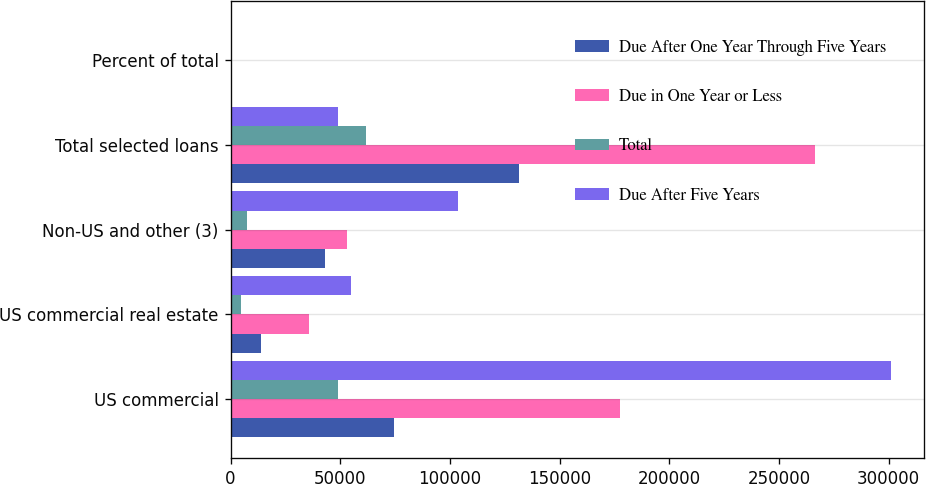Convert chart to OTSL. <chart><loc_0><loc_0><loc_500><loc_500><stacked_bar_chart><ecel><fcel>US commercial<fcel>US commercial real estate<fcel>Non-US and other (3)<fcel>Total selected loans<fcel>Percent of total<nl><fcel>Due After One Year Through Five Years<fcel>74563<fcel>14015<fcel>42933<fcel>131511<fcel>29<nl><fcel>Due in One Year or Less<fcel>177459<fcel>35741<fcel>53094<fcel>266294<fcel>58<nl><fcel>Total<fcel>49090<fcel>5005<fcel>7457<fcel>61552<fcel>13<nl><fcel>Due After Five Years<fcel>301112<fcel>54761<fcel>103484<fcel>49090<fcel>100<nl></chart> 